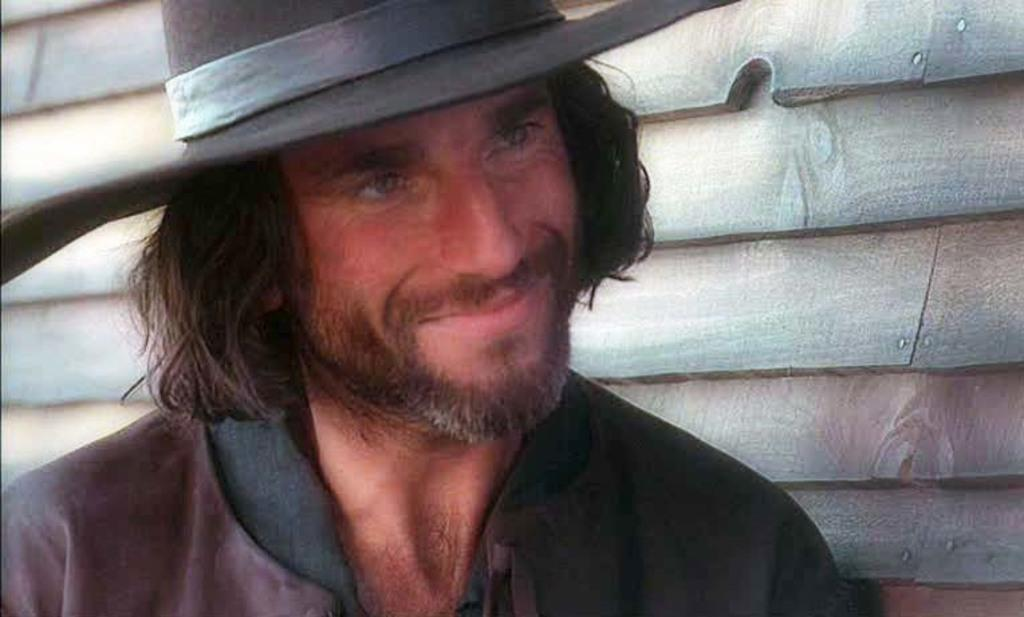What is the main subject of the image? There is a person in the image. Can you describe the person's clothing? The person is wearing a brown and black colored dress and a black colored hat. What can be seen in the background of the image? There is a wooden wall in the background of the image. How many mice are visible on the person's shoulder in the image? There are no mice visible on the person's shoulder in the image. What is the distance between the person and the dock in the image? There is no dock present in the image, so it is not possible to determine the distance between the person and a dock. 